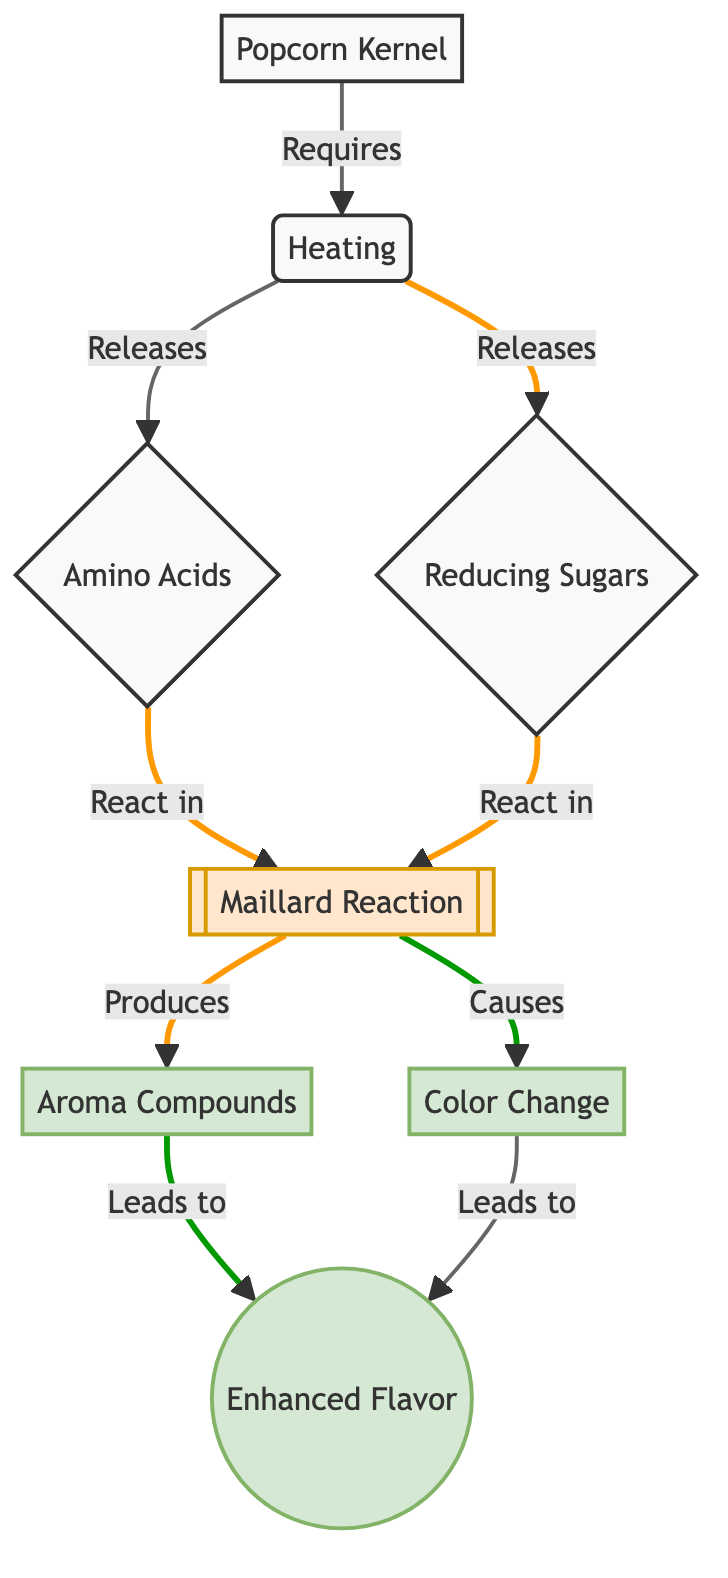What is the starting point of the reaction in the diagram? The starting point of the reaction in the diagram is labeled as "Popcorn Kernel". This is directly indicated in the diagram as node A.
Answer: Popcorn Kernel What is required for the Maillard Reaction to occur according to the diagram? The diagram states that “Heating” is required for the Maillard Reaction to occur. This is shown as the connection from node B (Heating) to the reaction node E (Maillard Reaction).
Answer: Heating How many Aroma Compounds are produced by the reaction? The diagram indicates that Aroma Compounds are produced as a result of the Maillard Reaction and is represented by one node labeled "Aroma Compounds". Thus, the number is one.
Answer: 1 What two substances are released during heating of the popcorn kernel? The diagram illustrates that two substances are released during heating: “Amino Acids” and “Reducing Sugars”, represented by nodes C and D respectively.
Answer: Amino Acids, Reducing Sugars What results from the Maillard Reaction apart from Aroma Compounds? Besides Aroma Compounds, the diagram shows that the Maillard Reaction also causes a "Color Change", noted as node G. Therefore, both Aroma Compounds and Color Change result from the reaction.
Answer: Color Change How does the Maillard Reaction affect the flavor of popcorn? The diagram indicates that the Maillard Reaction leads to “Enhanced Flavor”, which is the final output of both Aroma Compounds and Color Change. Thus, the impact on flavor is enhancement.
Answer: Enhanced Flavor What is the relationship between “Amino Acids” and the “Maillard Reaction”? According to the diagram, the relationship is that Amino Acids react in the Maillard Reaction. This is illustrated by the arrow connecting C (Amino Acids) to E (Maillard Reaction).
Answer: React in What causes the color change in popcorn during the heating process? The diagram suggests that the color change is caused by the Maillard Reaction, as shown by the arrow from node E to node G. Thus, the cause of the color change is the Maillard Reaction.
Answer: Maillard Reaction Which node contains the enhanced flavor output? The node that contains the enhanced flavor output is labeled as “Enhanced Flavor” and is represented by node H. This is clearly presented as the endpoint of multiple connections in the diagram.
Answer: Enhanced Flavor 